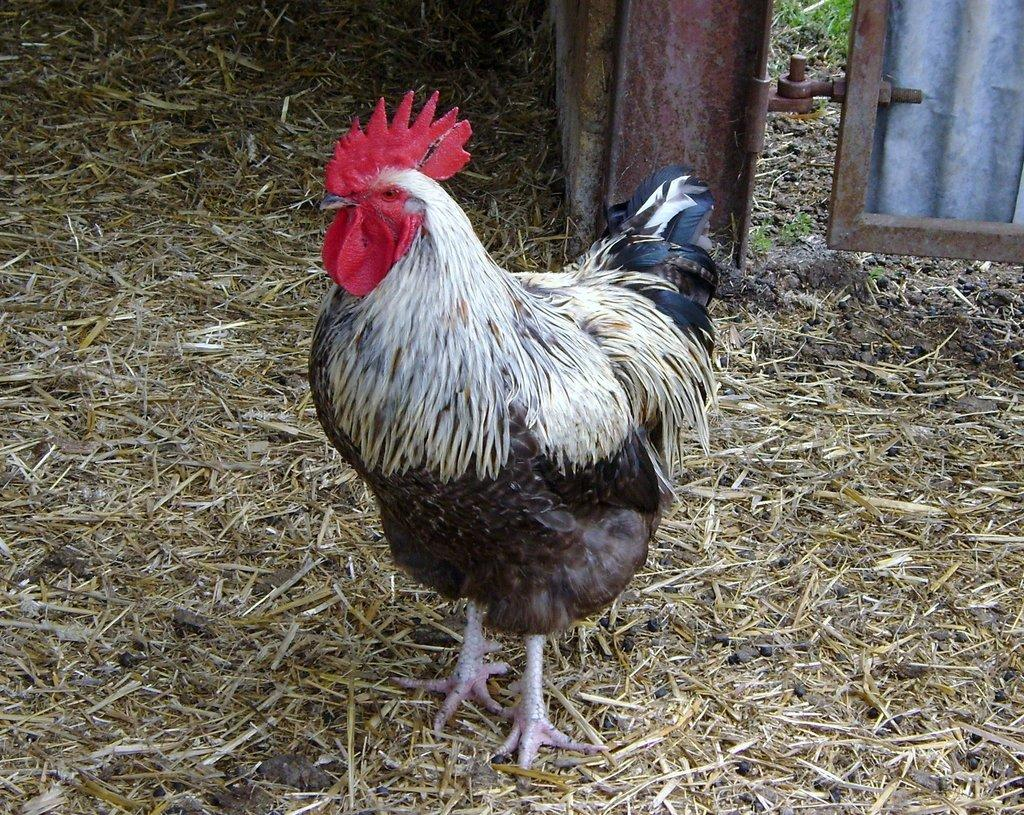What type of animal is in the image? There is a cock in the image. What is the cock doing in the image? The cock is standing on the ground. What type of vegetation is present at the bottom of the image? There is dry grass at the bottom of the image. What type of structure can be seen in the background of the image? There is a metal gate in the background of the image. Can you see any icicles hanging from the metal gate in the image? There are no icicles present in the image; it appears to be a dry and grassy area. 